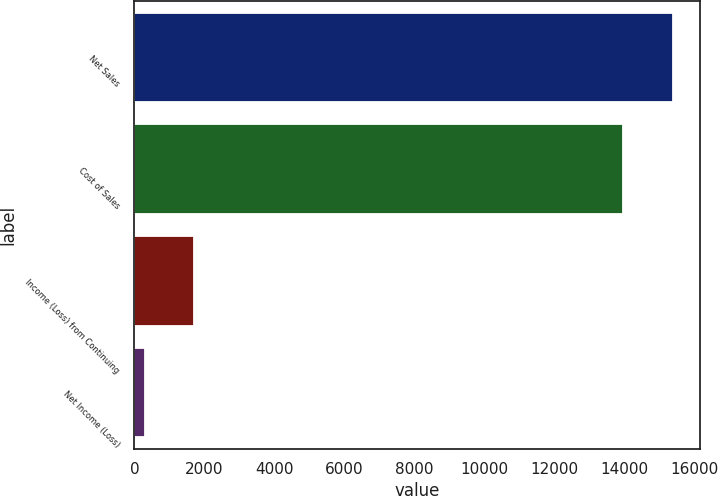<chart> <loc_0><loc_0><loc_500><loc_500><bar_chart><fcel>Net Sales<fcel>Cost of Sales<fcel>Income (Loss) from Continuing<fcel>Net Income (Loss)<nl><fcel>15390.7<fcel>13970<fcel>1717.7<fcel>297<nl></chart> 